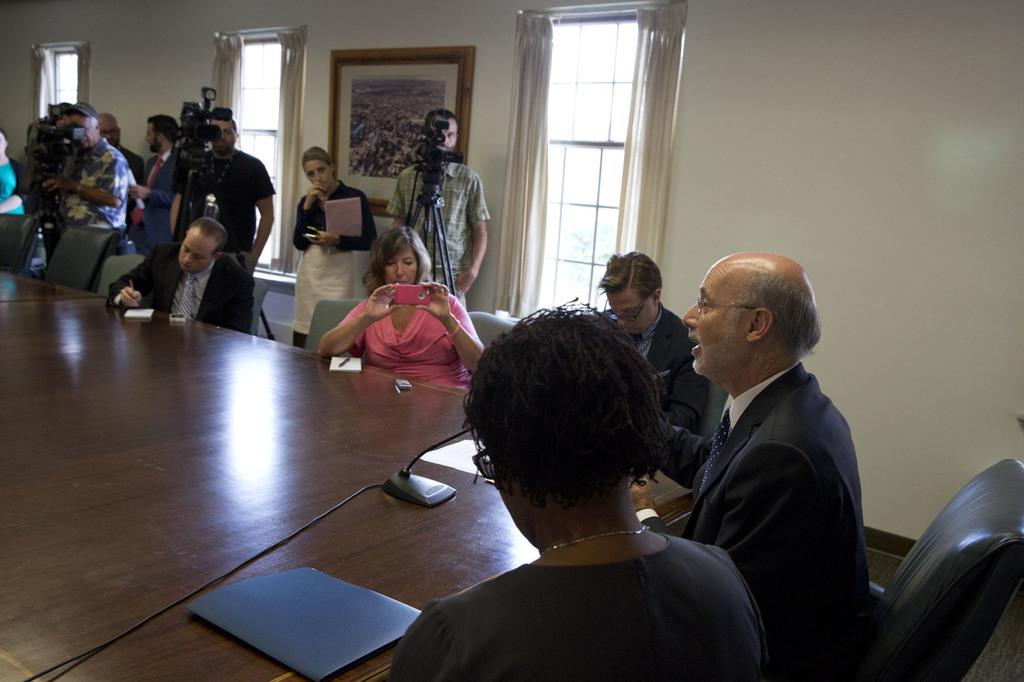How many people are in the image? There is a group of people in the image. What are some of the people in the image doing? Some people are sitting on chairs, while others are standing. What can be seen in the background of the image? There is a wall, windows, and curtains in the background of the image. What is the taste of the crook in the image? There is no crook present in the image, so it is not possible to determine its taste. 